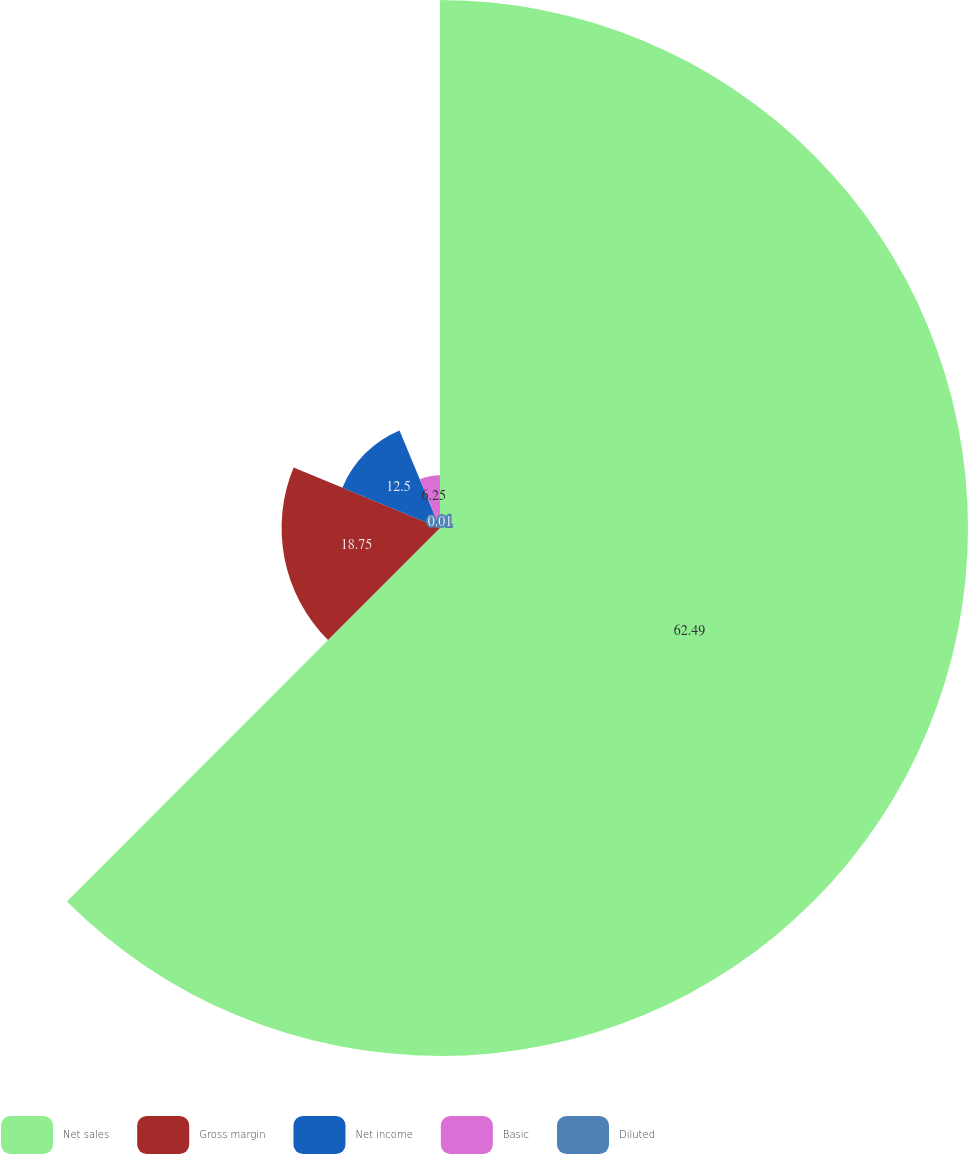Convert chart. <chart><loc_0><loc_0><loc_500><loc_500><pie_chart><fcel>Net sales<fcel>Gross margin<fcel>Net income<fcel>Basic<fcel>Diluted<nl><fcel>62.49%<fcel>18.75%<fcel>12.5%<fcel>6.25%<fcel>0.01%<nl></chart> 